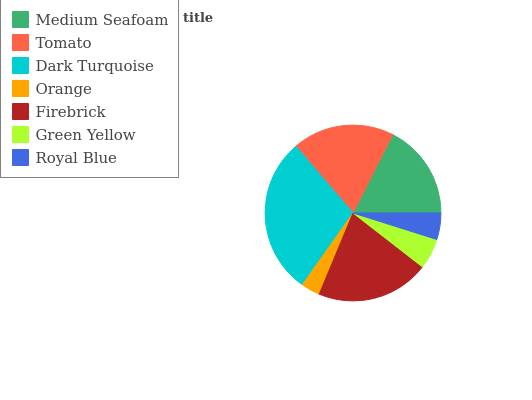Is Orange the minimum?
Answer yes or no. Yes. Is Dark Turquoise the maximum?
Answer yes or no. Yes. Is Tomato the minimum?
Answer yes or no. No. Is Tomato the maximum?
Answer yes or no. No. Is Tomato greater than Medium Seafoam?
Answer yes or no. Yes. Is Medium Seafoam less than Tomato?
Answer yes or no. Yes. Is Medium Seafoam greater than Tomato?
Answer yes or no. No. Is Tomato less than Medium Seafoam?
Answer yes or no. No. Is Medium Seafoam the high median?
Answer yes or no. Yes. Is Medium Seafoam the low median?
Answer yes or no. Yes. Is Dark Turquoise the high median?
Answer yes or no. No. Is Dark Turquoise the low median?
Answer yes or no. No. 